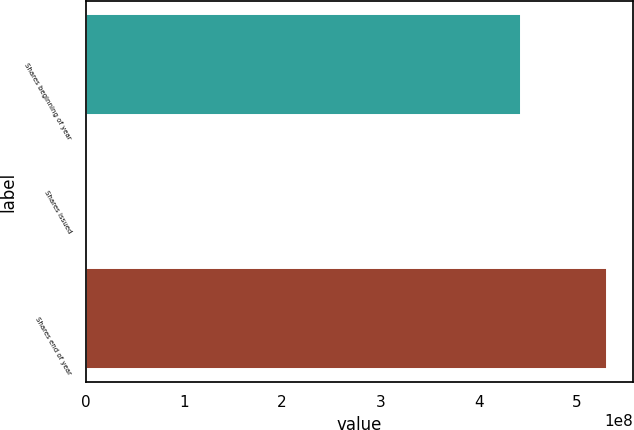<chart> <loc_0><loc_0><loc_500><loc_500><bar_chart><fcel>Shares beginning of year<fcel>Shares issued<fcel>Shares end of year<nl><fcel>4.42582e+08<fcel>15748<fcel>5.30745e+08<nl></chart> 